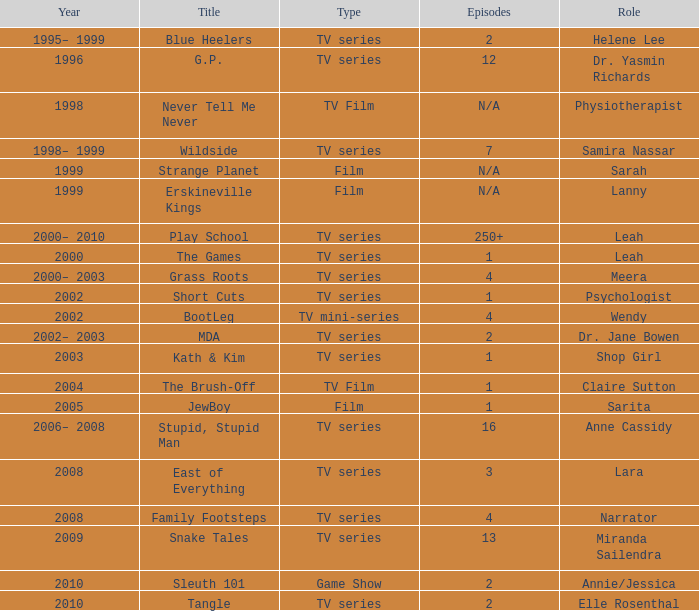What episode is called jewboy 1.0. 